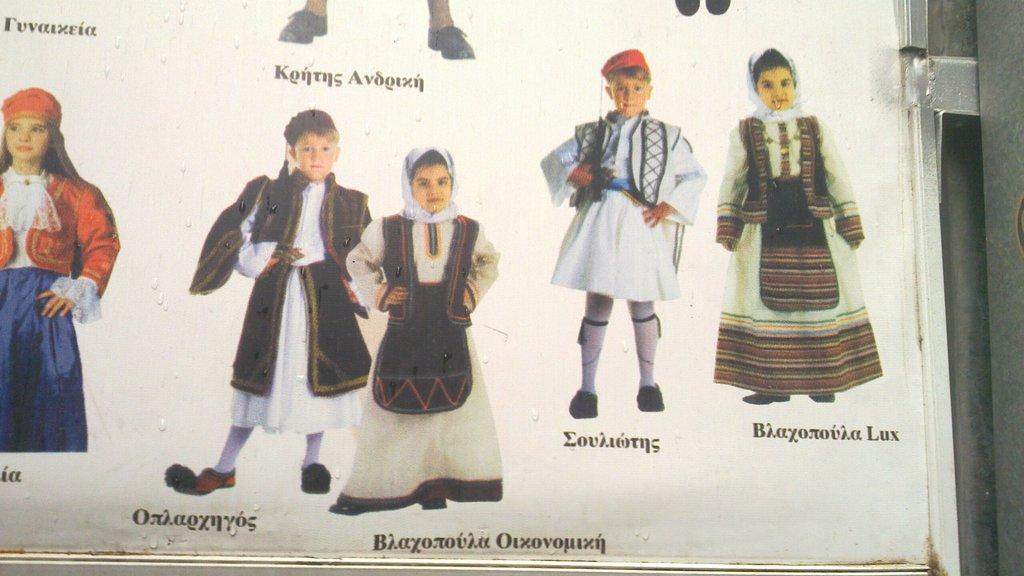What is the main subject of the image? There is a photo in the image. What can be seen in the photo? The photo contains children. What are the children wearing in the photo? The children are wearing costumes. How many bags can be seen in the image? There are no bags present in the image. What type of cherries are the children eating in the image? There are no cherries present in the image. 